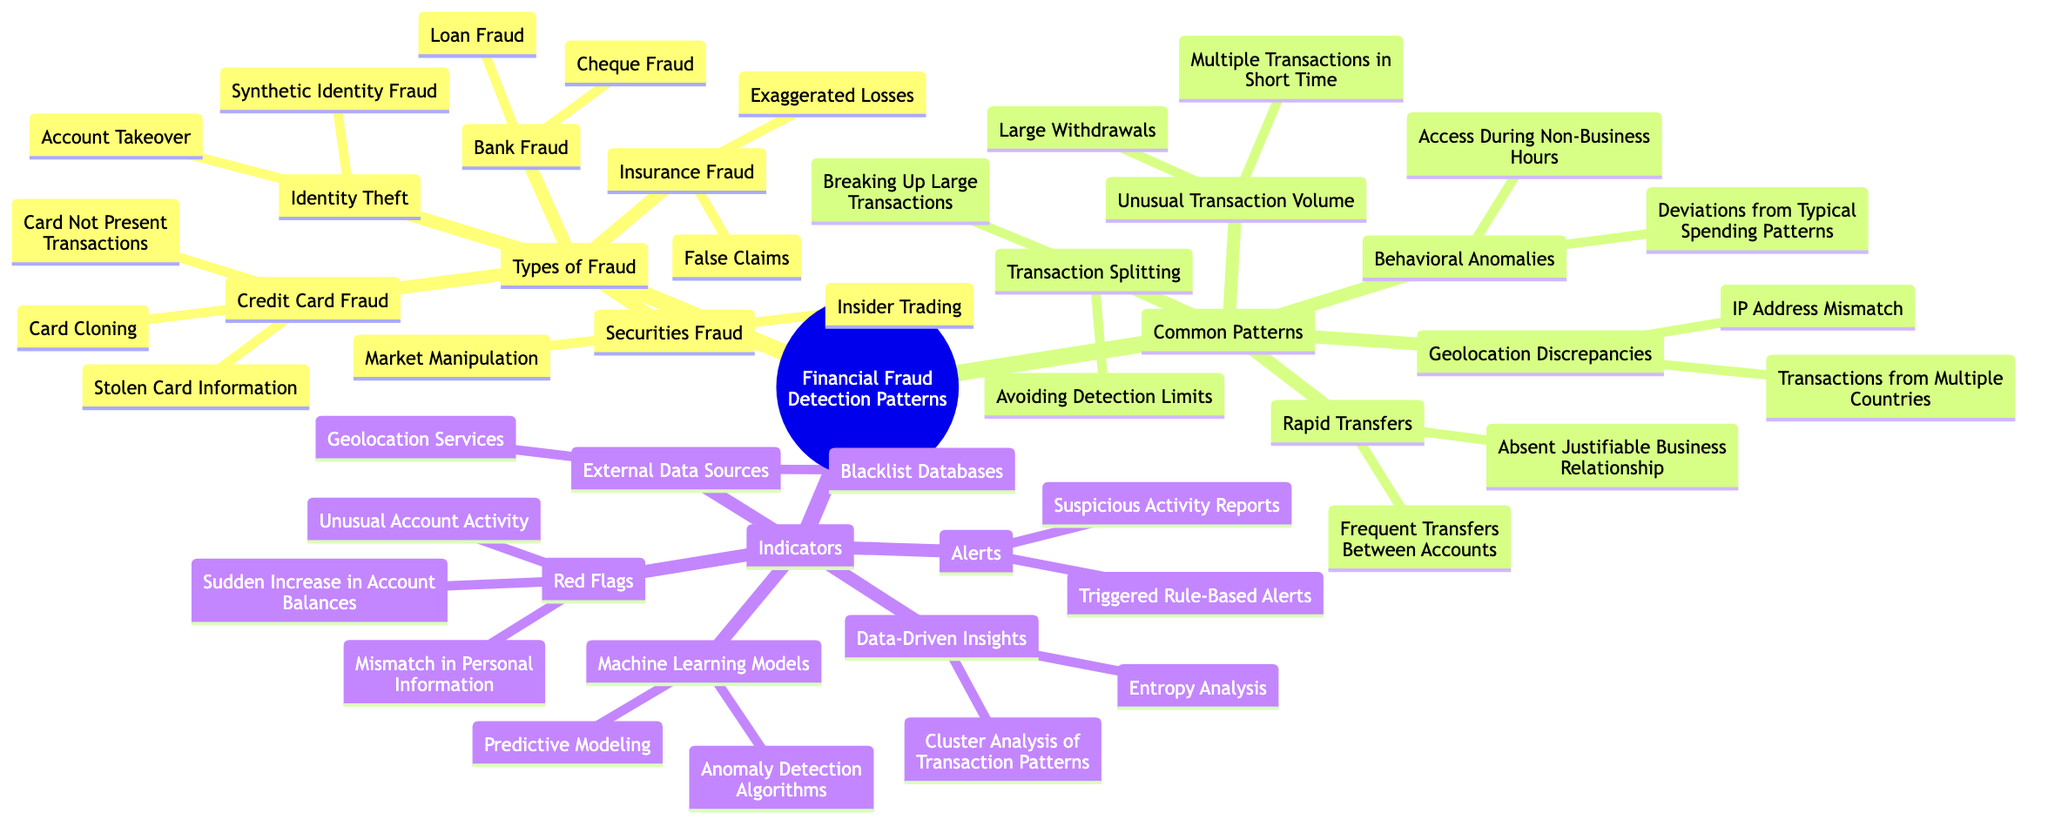What are the two types of fraud listed under Credit Card Fraud? The diagram shows "Card Not Present Transactions" and "Stolen Card Information" as the two types of fraud under Credit Card Fraud. This information can be found in the relevant node.
Answer: Card Not Present Transactions, Stolen Card Information How many common patterns are identified in the diagram? The diagram has a section for Common Patterns, which lists five distinct patterns: Unusual Transaction Volume, Geolocation Discrepancies, Behavioral Anomalies, Rapid Transfers, and Transaction Splitting. Therefore, counting these gives a total of five common patterns.
Answer: 5 Which type of fraud includes "Account Takeover"? According to the diagram, "Account Takeover" falls under the category of Identity Theft. This relationship can be easily traced from the main node labeled Types of Fraud down to its sub-category.
Answer: Identity Theft What is one indicator listed under Red Flags? The diagram specifies "Mismatch in Personal Information" as one of the indicators under the Red Flags section. This is outlined directly in the respective node.
Answer: Mismatch in Personal Information What relationship exists between "Anomaly Detection Algorithms" and Machine Learning Models? "Anomaly Detection Algorithms" is listed as a type of approach under the broader category of Machine Learning Models. To find this, one would start from the Indicators section, move to Machine Learning Models, and then note the sub-category.
Answer: Sub-category Which common pattern involves "Transactions from Multiple Countries"? The diagram presents "Transactions from Multiple Countries" as an example under the common pattern titled Geolocation Discrepancies. This connection can be traced in the Common Patterns section, illustrating how this specific transaction type fits into the larger category.
Answer: Geolocation Discrepancies How many types of fraud are mentioned in the diagram? In the Types of Fraud section, the diagram lists five different types: Credit Card Fraud, Identity Theft, Insurance Fraud, Securities Fraud, and Bank Fraud. By simply counting these listed categories, one arrives at the answer.
Answer: 5 What are the indicators categorized under Data-Driven Insights? The two indicators listed under Data-Driven Insights in the diagram are "Entropy Analysis" and "Cluster Analysis of Transaction Patterns". These details can be found by visiting the corresponding node in the Indicators section.
Answer: Entropy Analysis, Cluster Analysis of Transaction Patterns What is the purpose of the Alerts section in the Indicators? The Alerts section serves to identify specific alerts related to suspicious activities, featuring "Triggered Rule-Based Alerts" and "Suspicious Activity Reports" as possible alerts. By examining this part of the diagram, their relationship to fraud detection becomes clear.
Answer: To identify alerts related to suspicious activities 